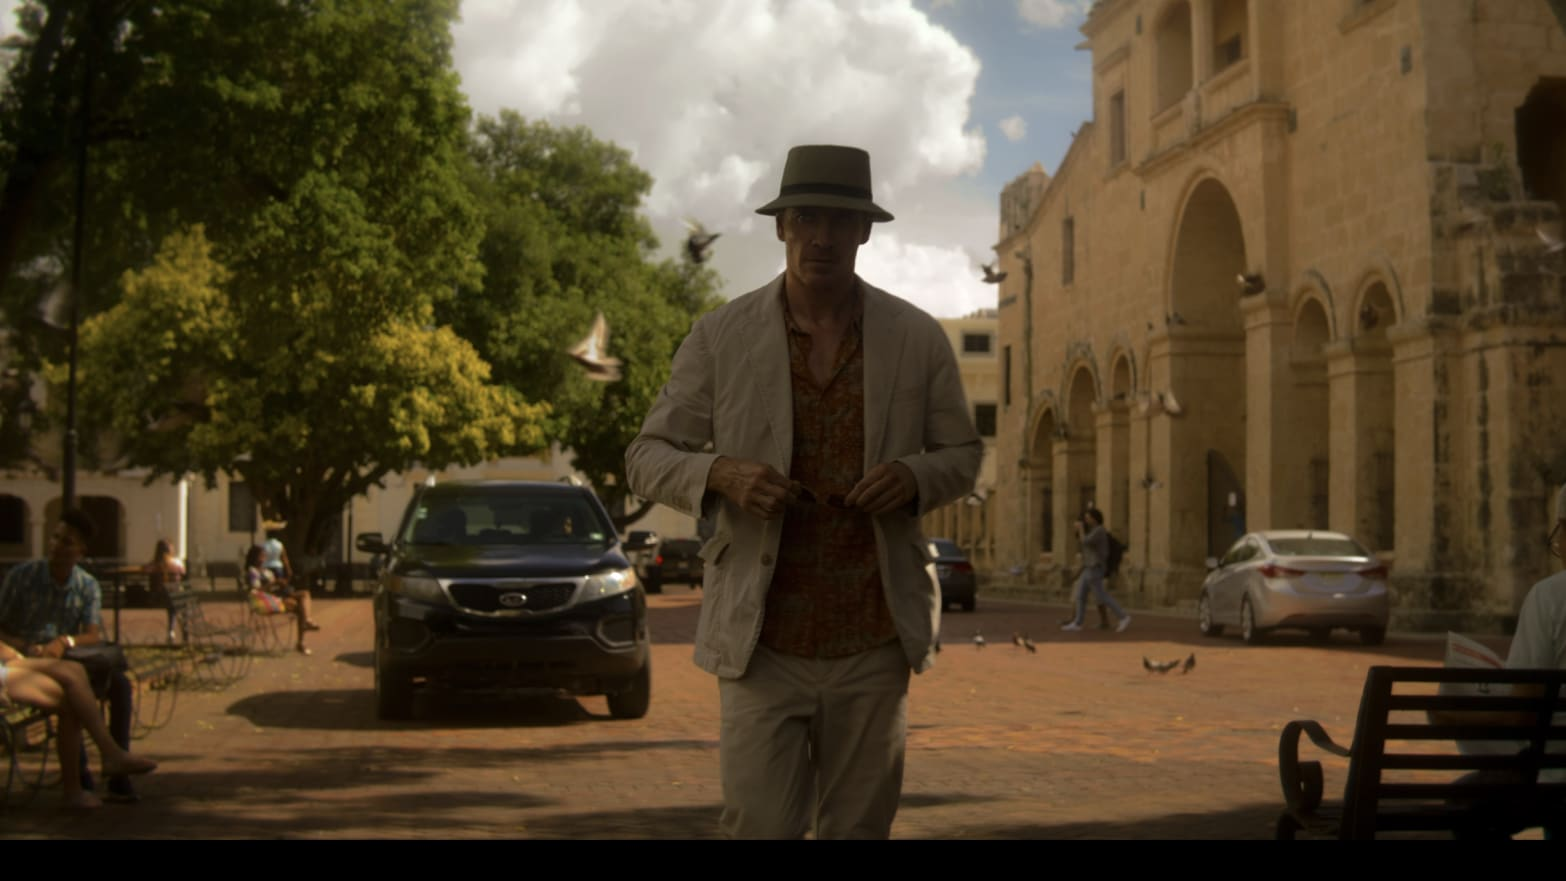What's happening in the scene? The image captures a man walking through what appears to be a lively street scene, emphasizing a relaxed, tropical ambiance. He is casually dressed in a white hat and light-colored jacket, seemingly focused on a task with his gaze directed downward. The background of the scene includes a historic church and bustling street activities, suggesting this might be in a popular tourist destination or a culturally rich locality. 